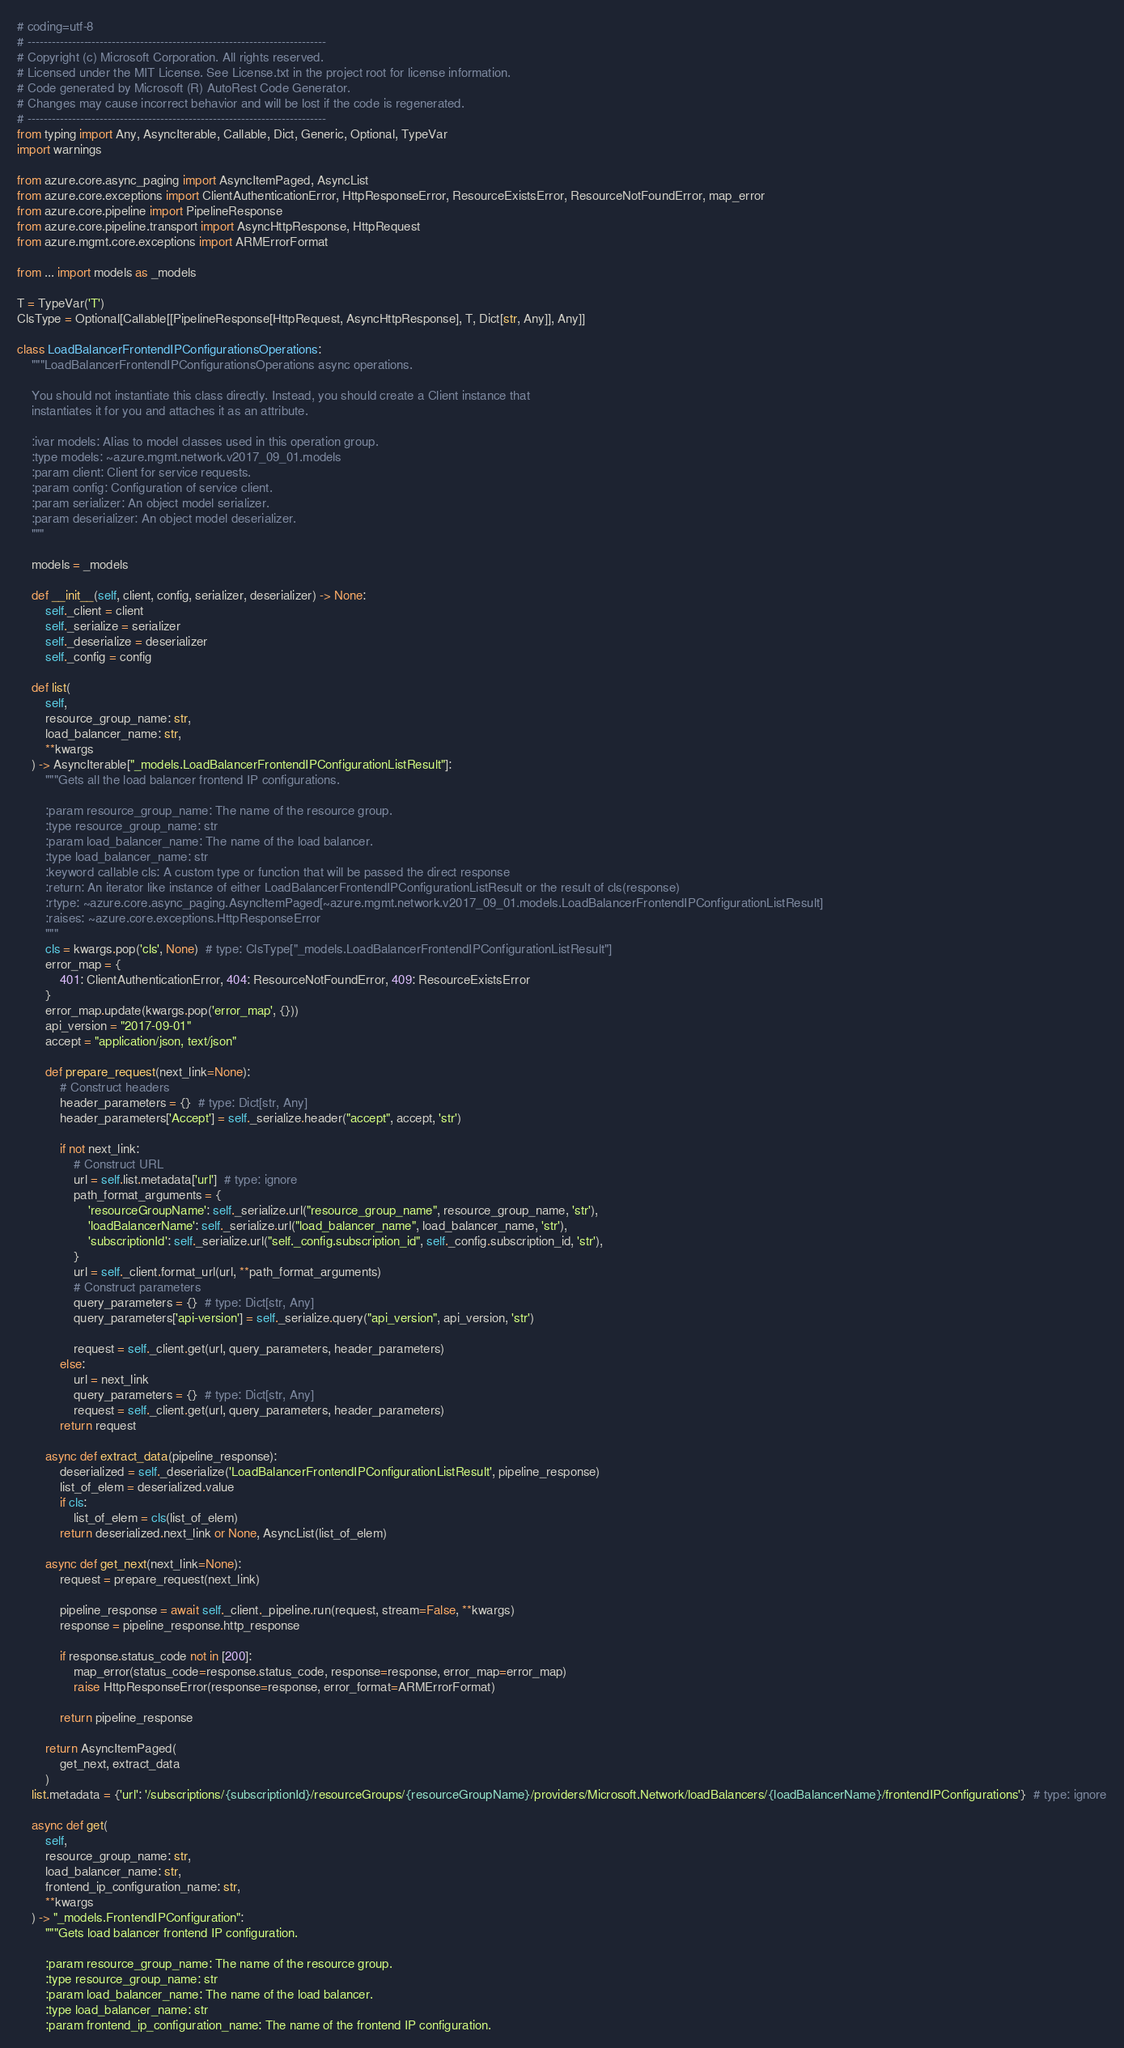Convert code to text. <code><loc_0><loc_0><loc_500><loc_500><_Python_># coding=utf-8
# --------------------------------------------------------------------------
# Copyright (c) Microsoft Corporation. All rights reserved.
# Licensed under the MIT License. See License.txt in the project root for license information.
# Code generated by Microsoft (R) AutoRest Code Generator.
# Changes may cause incorrect behavior and will be lost if the code is regenerated.
# --------------------------------------------------------------------------
from typing import Any, AsyncIterable, Callable, Dict, Generic, Optional, TypeVar
import warnings

from azure.core.async_paging import AsyncItemPaged, AsyncList
from azure.core.exceptions import ClientAuthenticationError, HttpResponseError, ResourceExistsError, ResourceNotFoundError, map_error
from azure.core.pipeline import PipelineResponse
from azure.core.pipeline.transport import AsyncHttpResponse, HttpRequest
from azure.mgmt.core.exceptions import ARMErrorFormat

from ... import models as _models

T = TypeVar('T')
ClsType = Optional[Callable[[PipelineResponse[HttpRequest, AsyncHttpResponse], T, Dict[str, Any]], Any]]

class LoadBalancerFrontendIPConfigurationsOperations:
    """LoadBalancerFrontendIPConfigurationsOperations async operations.

    You should not instantiate this class directly. Instead, you should create a Client instance that
    instantiates it for you and attaches it as an attribute.

    :ivar models: Alias to model classes used in this operation group.
    :type models: ~azure.mgmt.network.v2017_09_01.models
    :param client: Client for service requests.
    :param config: Configuration of service client.
    :param serializer: An object model serializer.
    :param deserializer: An object model deserializer.
    """

    models = _models

    def __init__(self, client, config, serializer, deserializer) -> None:
        self._client = client
        self._serialize = serializer
        self._deserialize = deserializer
        self._config = config

    def list(
        self,
        resource_group_name: str,
        load_balancer_name: str,
        **kwargs
    ) -> AsyncIterable["_models.LoadBalancerFrontendIPConfigurationListResult"]:
        """Gets all the load balancer frontend IP configurations.

        :param resource_group_name: The name of the resource group.
        :type resource_group_name: str
        :param load_balancer_name: The name of the load balancer.
        :type load_balancer_name: str
        :keyword callable cls: A custom type or function that will be passed the direct response
        :return: An iterator like instance of either LoadBalancerFrontendIPConfigurationListResult or the result of cls(response)
        :rtype: ~azure.core.async_paging.AsyncItemPaged[~azure.mgmt.network.v2017_09_01.models.LoadBalancerFrontendIPConfigurationListResult]
        :raises: ~azure.core.exceptions.HttpResponseError
        """
        cls = kwargs.pop('cls', None)  # type: ClsType["_models.LoadBalancerFrontendIPConfigurationListResult"]
        error_map = {
            401: ClientAuthenticationError, 404: ResourceNotFoundError, 409: ResourceExistsError
        }
        error_map.update(kwargs.pop('error_map', {}))
        api_version = "2017-09-01"
        accept = "application/json, text/json"

        def prepare_request(next_link=None):
            # Construct headers
            header_parameters = {}  # type: Dict[str, Any]
            header_parameters['Accept'] = self._serialize.header("accept", accept, 'str')

            if not next_link:
                # Construct URL
                url = self.list.metadata['url']  # type: ignore
                path_format_arguments = {
                    'resourceGroupName': self._serialize.url("resource_group_name", resource_group_name, 'str'),
                    'loadBalancerName': self._serialize.url("load_balancer_name", load_balancer_name, 'str'),
                    'subscriptionId': self._serialize.url("self._config.subscription_id", self._config.subscription_id, 'str'),
                }
                url = self._client.format_url(url, **path_format_arguments)
                # Construct parameters
                query_parameters = {}  # type: Dict[str, Any]
                query_parameters['api-version'] = self._serialize.query("api_version", api_version, 'str')

                request = self._client.get(url, query_parameters, header_parameters)
            else:
                url = next_link
                query_parameters = {}  # type: Dict[str, Any]
                request = self._client.get(url, query_parameters, header_parameters)
            return request

        async def extract_data(pipeline_response):
            deserialized = self._deserialize('LoadBalancerFrontendIPConfigurationListResult', pipeline_response)
            list_of_elem = deserialized.value
            if cls:
                list_of_elem = cls(list_of_elem)
            return deserialized.next_link or None, AsyncList(list_of_elem)

        async def get_next(next_link=None):
            request = prepare_request(next_link)

            pipeline_response = await self._client._pipeline.run(request, stream=False, **kwargs)
            response = pipeline_response.http_response

            if response.status_code not in [200]:
                map_error(status_code=response.status_code, response=response, error_map=error_map)
                raise HttpResponseError(response=response, error_format=ARMErrorFormat)

            return pipeline_response

        return AsyncItemPaged(
            get_next, extract_data
        )
    list.metadata = {'url': '/subscriptions/{subscriptionId}/resourceGroups/{resourceGroupName}/providers/Microsoft.Network/loadBalancers/{loadBalancerName}/frontendIPConfigurations'}  # type: ignore

    async def get(
        self,
        resource_group_name: str,
        load_balancer_name: str,
        frontend_ip_configuration_name: str,
        **kwargs
    ) -> "_models.FrontendIPConfiguration":
        """Gets load balancer frontend IP configuration.

        :param resource_group_name: The name of the resource group.
        :type resource_group_name: str
        :param load_balancer_name: The name of the load balancer.
        :type load_balancer_name: str
        :param frontend_ip_configuration_name: The name of the frontend IP configuration.</code> 